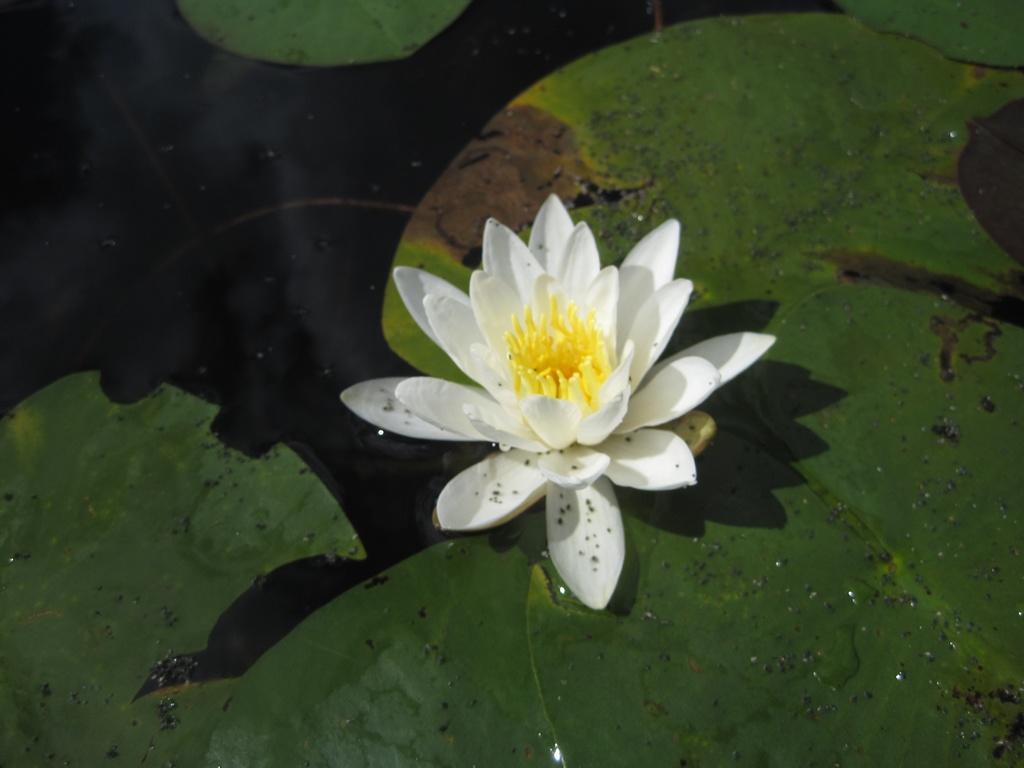Can you describe this image briefly? In the picture I can see the white lotus flower in the middle of the image and there are green leaves floating on the water. 